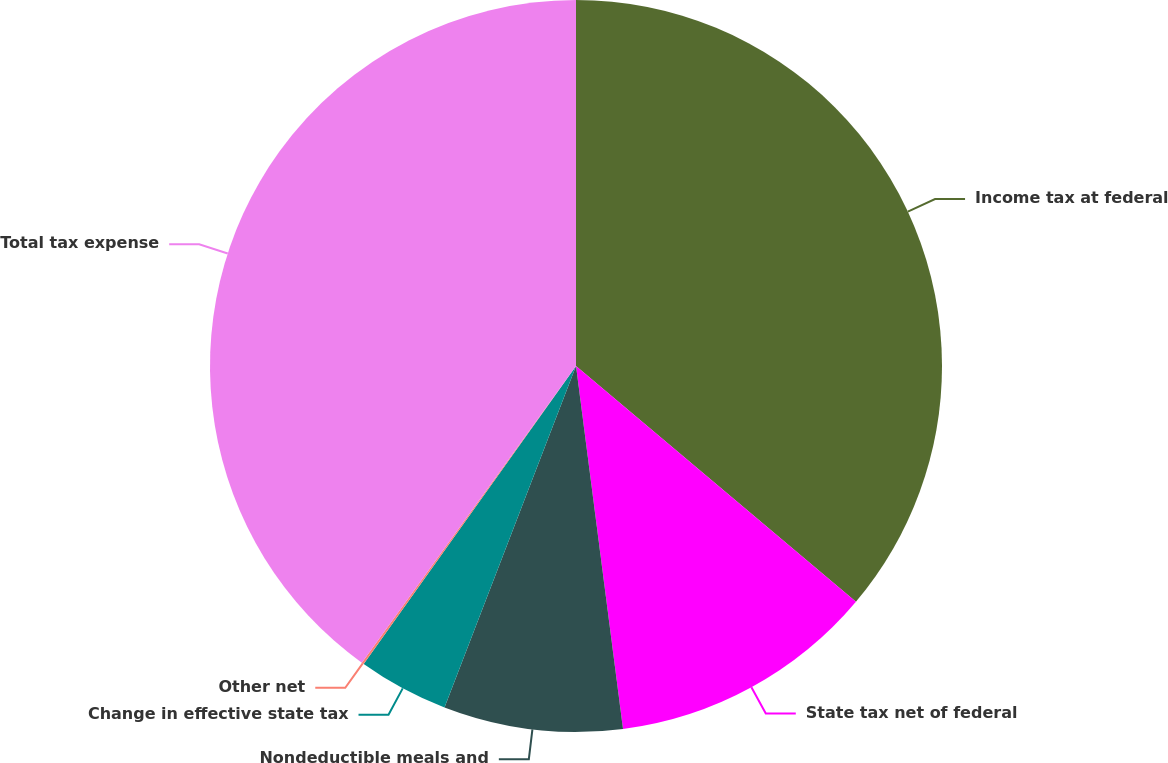<chart> <loc_0><loc_0><loc_500><loc_500><pie_chart><fcel>Income tax at federal<fcel>State tax net of federal<fcel>Nondeductible meals and<fcel>Change in effective state tax<fcel>Other net<fcel>Total tax expense<nl><fcel>36.14%<fcel>11.81%<fcel>7.9%<fcel>4.0%<fcel>0.1%<fcel>40.05%<nl></chart> 